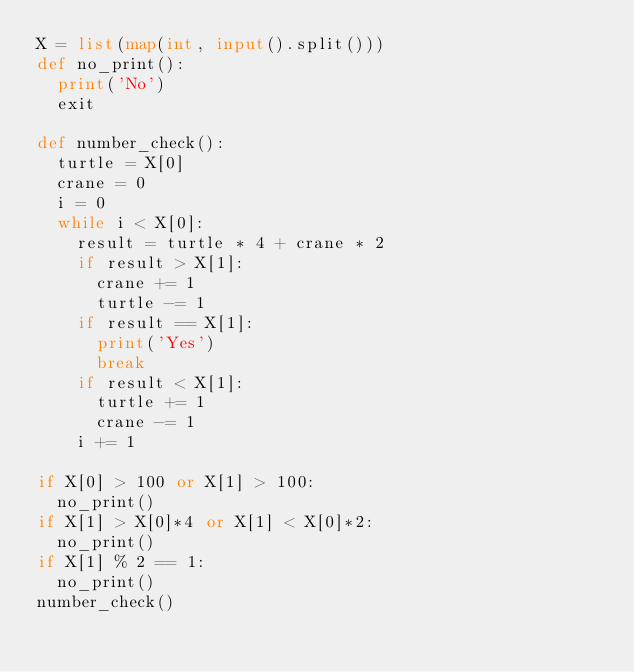<code> <loc_0><loc_0><loc_500><loc_500><_Python_>X = list(map(int, input().split()))
def no_print():
  print('No')
  exit
 
def number_check():
  turtle = X[0]
  crane = 0
  i = 0
  while i < X[0]:
    result = turtle * 4 + crane * 2 
    if result > X[1]:
      crane += 1
      turtle -= 1
    if result == X[1]:
      print('Yes')
      break
    if result < X[1]:
      turtle += 1
      crane -= 1
    i += 1

if X[0] > 100 or X[1] > 100:
  no_print()
if X[1] > X[0]*4 or X[1] < X[0]*2:
  no_print()
if X[1] % 2 == 1:
  no_print()
number_check()
</code> 